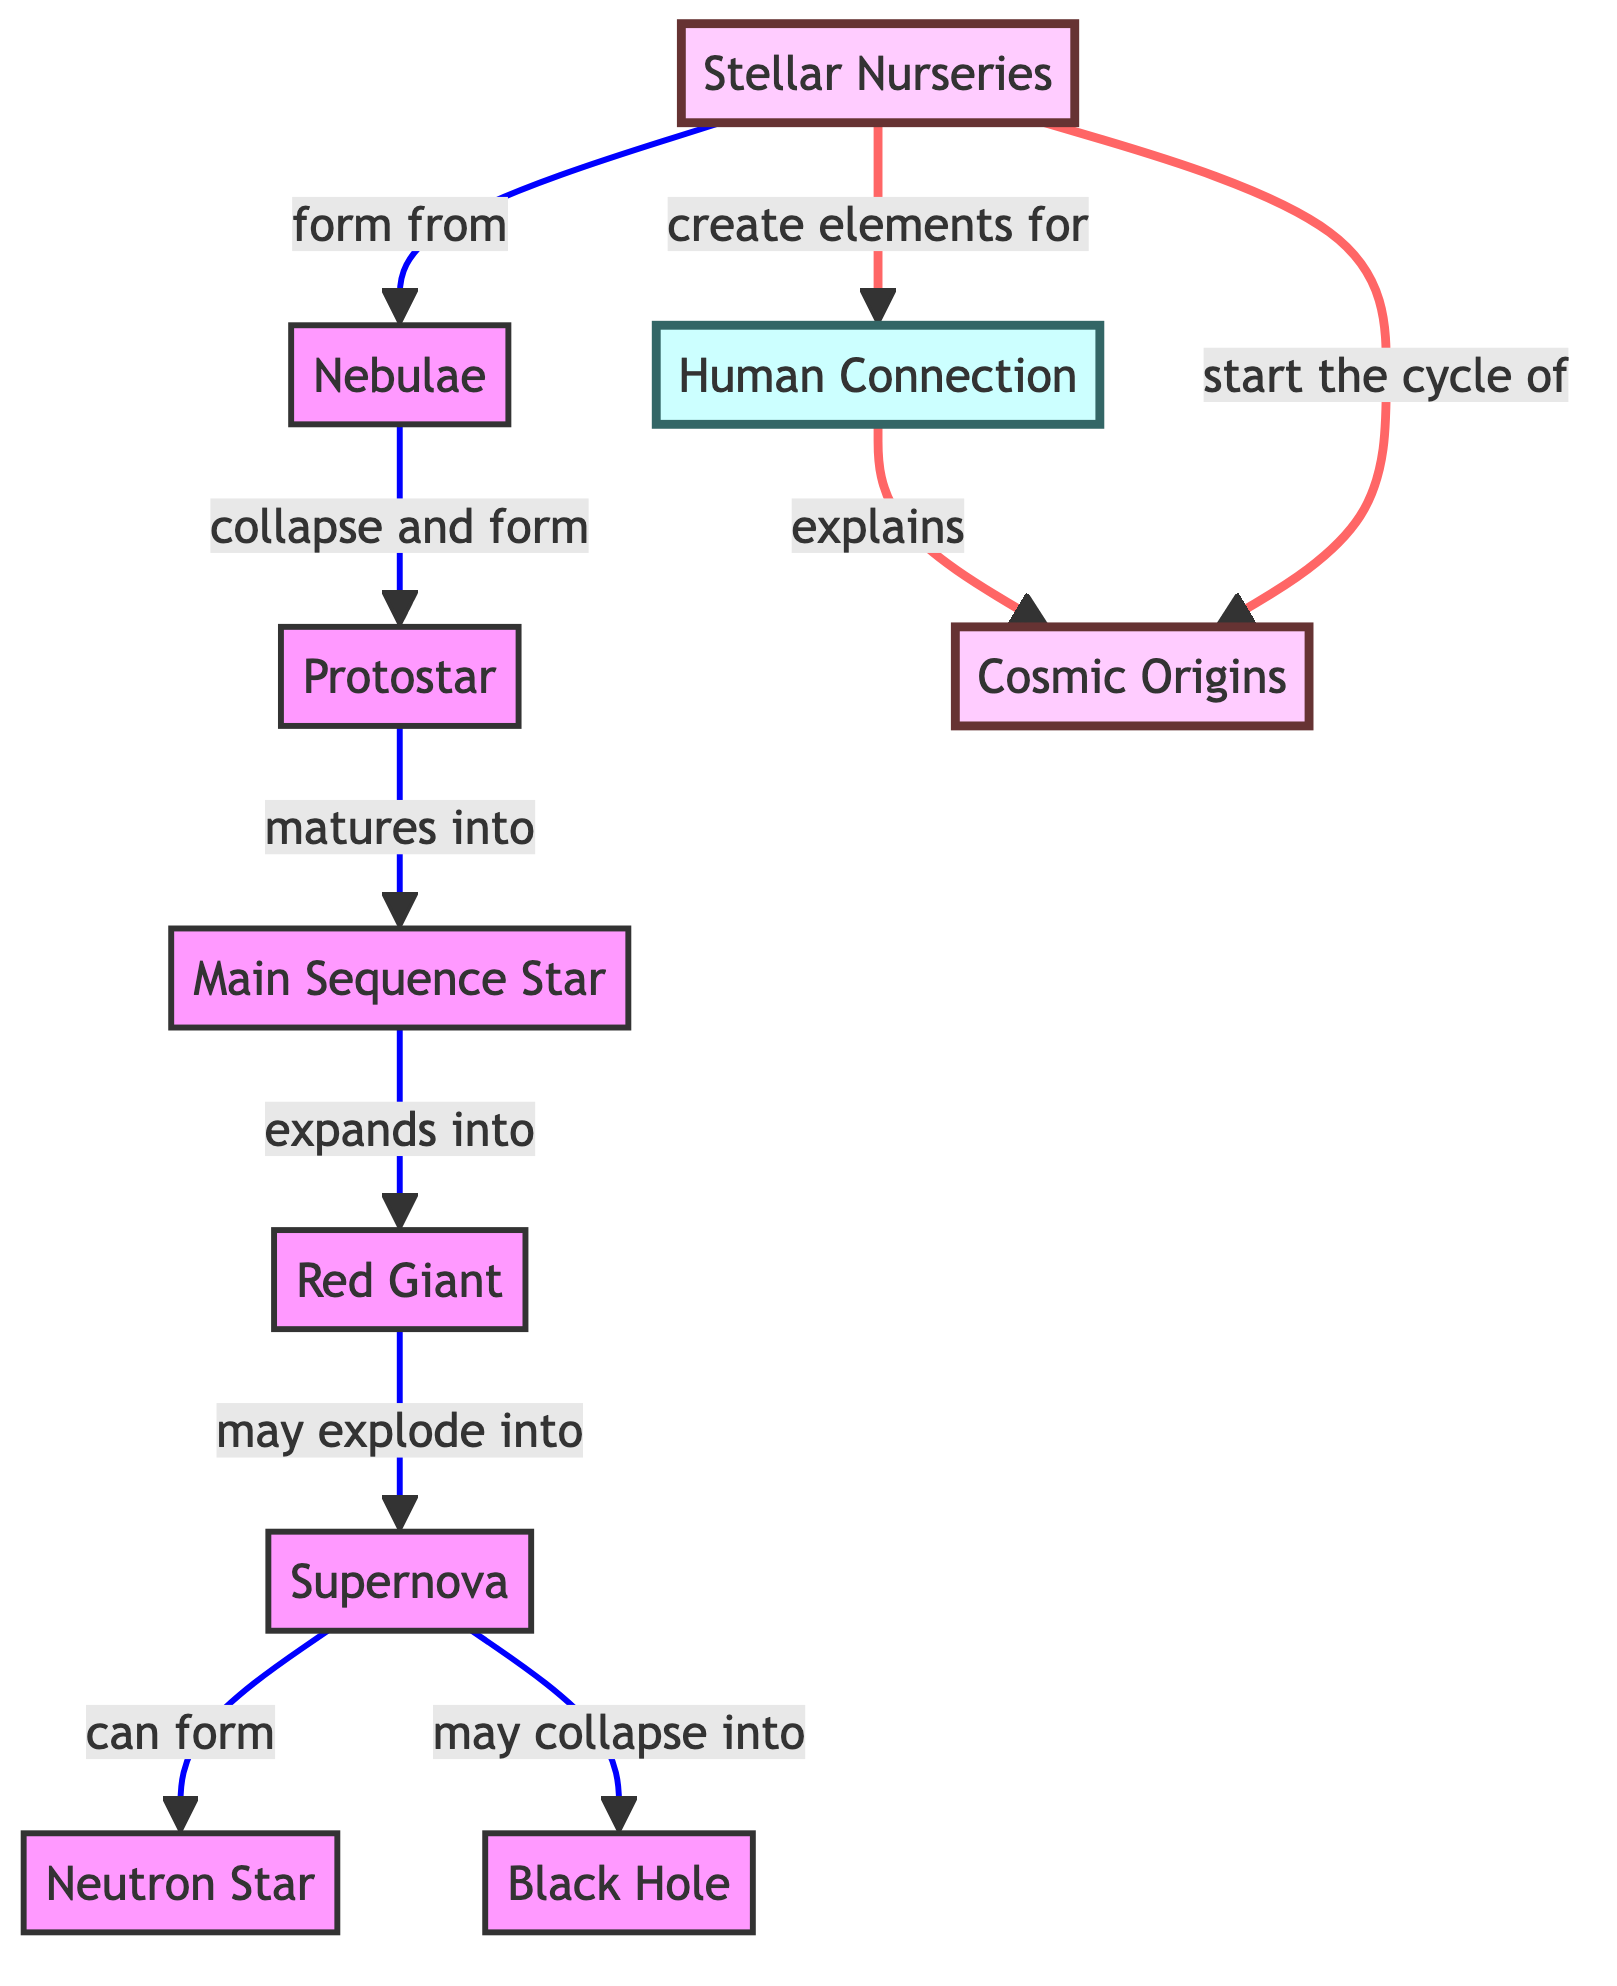What is the first stage of the star lifecycle according to the diagram? The diagram indicates that the first stage of the star lifecycle is "Nebulae," which is the initial form that ultimately leads to star formation.
Answer: Nebulae How many stages are there in the lifecycle of stars presented? By counting each node in the diagram that represents a stage, there are seven stages: Nebulae, Protostar, Main Sequence Star, Red Giant, Supernova, Neutron Star, and Black Hole.
Answer: Seven What connects "Stellar Nurseries" to "Human Connection"? The diagram illustrates a direct connection labeled "create elements for," which shows that Stellar Nurseries play a role in forming elements that are relevant to human existence.
Answer: Create elements for What happens to a Red Giant in the diagram? According to the diagram, a Red Giant may either explode into a Supernova or collapse into other forms such as a Neutron Star or a Black Hole.
Answer: May explode into Supernova What is the final endpoint in the life cycle of stars according to the diagram? The diagram indicates two potential endpoints for a star's lifecycle: either a Neutron Star or a Black Hole, both arising from the Supernova stage.
Answer: Neutron Star or Black Hole How do Stellar Nurseries relate to Cosmic Origins? The diagram shows two connections between Stellar Nurseries and Cosmic Origins, one signaling that Stellar Nurseries start the cycle of Cosmic Origins and another that pertains to the explanation of Human Connection. This illustrates the fundamental link from star formation to the origins of the cosmos and human existence.
Answer: Start the cycle of Cosmic Origins and explains Cosmic Origins What is formed from the Supernova stage? The diagram indicates that from the Supernova stage, two potential outcomes are represented: it can form a Neutron Star or collapse into a Black Hole.
Answer: Neutron Star or Black Hole 